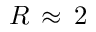<formula> <loc_0><loc_0><loc_500><loc_500>R \, \approx \, 2</formula> 